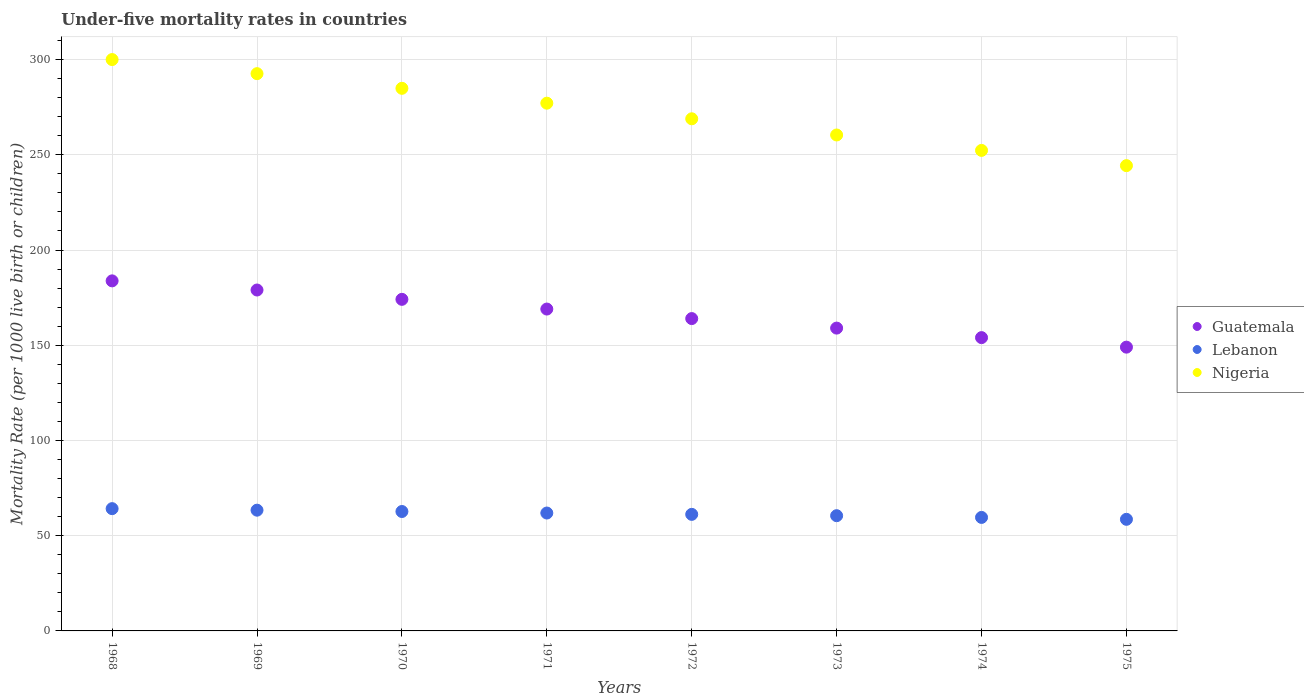How many different coloured dotlines are there?
Make the answer very short. 3. What is the under-five mortality rate in Nigeria in 1972?
Your answer should be compact. 268.9. Across all years, what is the maximum under-five mortality rate in Lebanon?
Give a very brief answer. 64.2. Across all years, what is the minimum under-five mortality rate in Nigeria?
Your answer should be very brief. 244.3. In which year was the under-five mortality rate in Nigeria maximum?
Your answer should be very brief. 1968. In which year was the under-five mortality rate in Nigeria minimum?
Your answer should be very brief. 1975. What is the total under-five mortality rate in Lebanon in the graph?
Offer a very short reply. 492.1. What is the difference between the under-five mortality rate in Nigeria in 1969 and the under-five mortality rate in Lebanon in 1968?
Provide a succinct answer. 228.4. What is the average under-five mortality rate in Lebanon per year?
Your answer should be very brief. 61.51. In the year 1970, what is the difference between the under-five mortality rate in Lebanon and under-five mortality rate in Guatemala?
Your response must be concise. -111.4. What is the ratio of the under-five mortality rate in Guatemala in 1969 to that in 1971?
Keep it short and to the point. 1.06. Is the under-five mortality rate in Guatemala in 1974 less than that in 1975?
Your answer should be compact. No. What is the difference between the highest and the second highest under-five mortality rate in Lebanon?
Provide a short and direct response. 0.8. What is the difference between the highest and the lowest under-five mortality rate in Nigeria?
Offer a terse response. 55.7. Is the sum of the under-five mortality rate in Guatemala in 1968 and 1973 greater than the maximum under-five mortality rate in Nigeria across all years?
Offer a very short reply. Yes. Does the under-five mortality rate in Nigeria monotonically increase over the years?
Provide a short and direct response. No. Is the under-five mortality rate in Guatemala strictly less than the under-five mortality rate in Lebanon over the years?
Make the answer very short. No. How many dotlines are there?
Keep it short and to the point. 3. Are the values on the major ticks of Y-axis written in scientific E-notation?
Offer a terse response. No. Does the graph contain any zero values?
Give a very brief answer. No. Does the graph contain grids?
Make the answer very short. Yes. How many legend labels are there?
Offer a very short reply. 3. How are the legend labels stacked?
Offer a terse response. Vertical. What is the title of the graph?
Provide a succinct answer. Under-five mortality rates in countries. What is the label or title of the Y-axis?
Make the answer very short. Mortality Rate (per 1000 live birth or children). What is the Mortality Rate (per 1000 live birth or children) of Guatemala in 1968?
Provide a short and direct response. 183.8. What is the Mortality Rate (per 1000 live birth or children) of Lebanon in 1968?
Ensure brevity in your answer.  64.2. What is the Mortality Rate (per 1000 live birth or children) of Nigeria in 1968?
Give a very brief answer. 300. What is the Mortality Rate (per 1000 live birth or children) of Guatemala in 1969?
Give a very brief answer. 179. What is the Mortality Rate (per 1000 live birth or children) of Lebanon in 1969?
Your response must be concise. 63.4. What is the Mortality Rate (per 1000 live birth or children) in Nigeria in 1969?
Make the answer very short. 292.6. What is the Mortality Rate (per 1000 live birth or children) in Guatemala in 1970?
Ensure brevity in your answer.  174.1. What is the Mortality Rate (per 1000 live birth or children) of Lebanon in 1970?
Provide a succinct answer. 62.7. What is the Mortality Rate (per 1000 live birth or children) of Nigeria in 1970?
Offer a very short reply. 284.9. What is the Mortality Rate (per 1000 live birth or children) of Guatemala in 1971?
Provide a succinct answer. 169. What is the Mortality Rate (per 1000 live birth or children) in Lebanon in 1971?
Ensure brevity in your answer.  61.9. What is the Mortality Rate (per 1000 live birth or children) of Nigeria in 1971?
Keep it short and to the point. 277.1. What is the Mortality Rate (per 1000 live birth or children) in Guatemala in 1972?
Provide a succinct answer. 164. What is the Mortality Rate (per 1000 live birth or children) in Lebanon in 1972?
Make the answer very short. 61.2. What is the Mortality Rate (per 1000 live birth or children) in Nigeria in 1972?
Your answer should be compact. 268.9. What is the Mortality Rate (per 1000 live birth or children) in Guatemala in 1973?
Your answer should be very brief. 159. What is the Mortality Rate (per 1000 live birth or children) of Lebanon in 1973?
Make the answer very short. 60.5. What is the Mortality Rate (per 1000 live birth or children) in Nigeria in 1973?
Offer a very short reply. 260.4. What is the Mortality Rate (per 1000 live birth or children) of Guatemala in 1974?
Offer a very short reply. 154. What is the Mortality Rate (per 1000 live birth or children) of Lebanon in 1974?
Ensure brevity in your answer.  59.6. What is the Mortality Rate (per 1000 live birth or children) of Nigeria in 1974?
Provide a succinct answer. 252.3. What is the Mortality Rate (per 1000 live birth or children) of Guatemala in 1975?
Make the answer very short. 149. What is the Mortality Rate (per 1000 live birth or children) of Lebanon in 1975?
Ensure brevity in your answer.  58.6. What is the Mortality Rate (per 1000 live birth or children) of Nigeria in 1975?
Give a very brief answer. 244.3. Across all years, what is the maximum Mortality Rate (per 1000 live birth or children) of Guatemala?
Offer a terse response. 183.8. Across all years, what is the maximum Mortality Rate (per 1000 live birth or children) of Lebanon?
Keep it short and to the point. 64.2. Across all years, what is the maximum Mortality Rate (per 1000 live birth or children) in Nigeria?
Give a very brief answer. 300. Across all years, what is the minimum Mortality Rate (per 1000 live birth or children) in Guatemala?
Offer a very short reply. 149. Across all years, what is the minimum Mortality Rate (per 1000 live birth or children) of Lebanon?
Make the answer very short. 58.6. Across all years, what is the minimum Mortality Rate (per 1000 live birth or children) of Nigeria?
Your response must be concise. 244.3. What is the total Mortality Rate (per 1000 live birth or children) of Guatemala in the graph?
Ensure brevity in your answer.  1331.9. What is the total Mortality Rate (per 1000 live birth or children) of Lebanon in the graph?
Your answer should be compact. 492.1. What is the total Mortality Rate (per 1000 live birth or children) of Nigeria in the graph?
Offer a terse response. 2180.5. What is the difference between the Mortality Rate (per 1000 live birth or children) of Lebanon in 1968 and that in 1969?
Ensure brevity in your answer.  0.8. What is the difference between the Mortality Rate (per 1000 live birth or children) of Lebanon in 1968 and that in 1970?
Your response must be concise. 1.5. What is the difference between the Mortality Rate (per 1000 live birth or children) of Nigeria in 1968 and that in 1971?
Ensure brevity in your answer.  22.9. What is the difference between the Mortality Rate (per 1000 live birth or children) of Guatemala in 1968 and that in 1972?
Ensure brevity in your answer.  19.8. What is the difference between the Mortality Rate (per 1000 live birth or children) of Lebanon in 1968 and that in 1972?
Offer a very short reply. 3. What is the difference between the Mortality Rate (per 1000 live birth or children) of Nigeria in 1968 and that in 1972?
Ensure brevity in your answer.  31.1. What is the difference between the Mortality Rate (per 1000 live birth or children) of Guatemala in 1968 and that in 1973?
Make the answer very short. 24.8. What is the difference between the Mortality Rate (per 1000 live birth or children) in Lebanon in 1968 and that in 1973?
Make the answer very short. 3.7. What is the difference between the Mortality Rate (per 1000 live birth or children) of Nigeria in 1968 and that in 1973?
Your answer should be compact. 39.6. What is the difference between the Mortality Rate (per 1000 live birth or children) in Guatemala in 1968 and that in 1974?
Keep it short and to the point. 29.8. What is the difference between the Mortality Rate (per 1000 live birth or children) in Lebanon in 1968 and that in 1974?
Ensure brevity in your answer.  4.6. What is the difference between the Mortality Rate (per 1000 live birth or children) in Nigeria in 1968 and that in 1974?
Your answer should be compact. 47.7. What is the difference between the Mortality Rate (per 1000 live birth or children) in Guatemala in 1968 and that in 1975?
Offer a very short reply. 34.8. What is the difference between the Mortality Rate (per 1000 live birth or children) of Lebanon in 1968 and that in 1975?
Provide a succinct answer. 5.6. What is the difference between the Mortality Rate (per 1000 live birth or children) in Nigeria in 1968 and that in 1975?
Provide a short and direct response. 55.7. What is the difference between the Mortality Rate (per 1000 live birth or children) in Guatemala in 1969 and that in 1971?
Make the answer very short. 10. What is the difference between the Mortality Rate (per 1000 live birth or children) in Lebanon in 1969 and that in 1971?
Offer a terse response. 1.5. What is the difference between the Mortality Rate (per 1000 live birth or children) in Nigeria in 1969 and that in 1972?
Your answer should be compact. 23.7. What is the difference between the Mortality Rate (per 1000 live birth or children) of Lebanon in 1969 and that in 1973?
Keep it short and to the point. 2.9. What is the difference between the Mortality Rate (per 1000 live birth or children) in Nigeria in 1969 and that in 1973?
Make the answer very short. 32.2. What is the difference between the Mortality Rate (per 1000 live birth or children) of Lebanon in 1969 and that in 1974?
Give a very brief answer. 3.8. What is the difference between the Mortality Rate (per 1000 live birth or children) of Nigeria in 1969 and that in 1974?
Your response must be concise. 40.3. What is the difference between the Mortality Rate (per 1000 live birth or children) in Lebanon in 1969 and that in 1975?
Offer a terse response. 4.8. What is the difference between the Mortality Rate (per 1000 live birth or children) of Nigeria in 1969 and that in 1975?
Your answer should be very brief. 48.3. What is the difference between the Mortality Rate (per 1000 live birth or children) in Lebanon in 1970 and that in 1971?
Your answer should be very brief. 0.8. What is the difference between the Mortality Rate (per 1000 live birth or children) of Lebanon in 1970 and that in 1972?
Keep it short and to the point. 1.5. What is the difference between the Mortality Rate (per 1000 live birth or children) in Nigeria in 1970 and that in 1972?
Offer a very short reply. 16. What is the difference between the Mortality Rate (per 1000 live birth or children) of Guatemala in 1970 and that in 1973?
Your answer should be very brief. 15.1. What is the difference between the Mortality Rate (per 1000 live birth or children) in Nigeria in 1970 and that in 1973?
Provide a succinct answer. 24.5. What is the difference between the Mortality Rate (per 1000 live birth or children) of Guatemala in 1970 and that in 1974?
Offer a very short reply. 20.1. What is the difference between the Mortality Rate (per 1000 live birth or children) in Lebanon in 1970 and that in 1974?
Offer a very short reply. 3.1. What is the difference between the Mortality Rate (per 1000 live birth or children) of Nigeria in 1970 and that in 1974?
Offer a very short reply. 32.6. What is the difference between the Mortality Rate (per 1000 live birth or children) of Guatemala in 1970 and that in 1975?
Your answer should be very brief. 25.1. What is the difference between the Mortality Rate (per 1000 live birth or children) in Nigeria in 1970 and that in 1975?
Provide a short and direct response. 40.6. What is the difference between the Mortality Rate (per 1000 live birth or children) of Guatemala in 1971 and that in 1972?
Your answer should be compact. 5. What is the difference between the Mortality Rate (per 1000 live birth or children) in Lebanon in 1971 and that in 1972?
Keep it short and to the point. 0.7. What is the difference between the Mortality Rate (per 1000 live birth or children) in Nigeria in 1971 and that in 1972?
Offer a very short reply. 8.2. What is the difference between the Mortality Rate (per 1000 live birth or children) in Lebanon in 1971 and that in 1973?
Ensure brevity in your answer.  1.4. What is the difference between the Mortality Rate (per 1000 live birth or children) of Guatemala in 1971 and that in 1974?
Keep it short and to the point. 15. What is the difference between the Mortality Rate (per 1000 live birth or children) of Lebanon in 1971 and that in 1974?
Offer a terse response. 2.3. What is the difference between the Mortality Rate (per 1000 live birth or children) of Nigeria in 1971 and that in 1974?
Offer a very short reply. 24.8. What is the difference between the Mortality Rate (per 1000 live birth or children) in Guatemala in 1971 and that in 1975?
Keep it short and to the point. 20. What is the difference between the Mortality Rate (per 1000 live birth or children) in Lebanon in 1971 and that in 1975?
Offer a terse response. 3.3. What is the difference between the Mortality Rate (per 1000 live birth or children) of Nigeria in 1971 and that in 1975?
Offer a very short reply. 32.8. What is the difference between the Mortality Rate (per 1000 live birth or children) of Lebanon in 1972 and that in 1973?
Offer a terse response. 0.7. What is the difference between the Mortality Rate (per 1000 live birth or children) of Lebanon in 1972 and that in 1974?
Provide a short and direct response. 1.6. What is the difference between the Mortality Rate (per 1000 live birth or children) in Nigeria in 1972 and that in 1974?
Ensure brevity in your answer.  16.6. What is the difference between the Mortality Rate (per 1000 live birth or children) in Lebanon in 1972 and that in 1975?
Your answer should be compact. 2.6. What is the difference between the Mortality Rate (per 1000 live birth or children) in Nigeria in 1972 and that in 1975?
Keep it short and to the point. 24.6. What is the difference between the Mortality Rate (per 1000 live birth or children) in Nigeria in 1973 and that in 1975?
Provide a succinct answer. 16.1. What is the difference between the Mortality Rate (per 1000 live birth or children) of Guatemala in 1974 and that in 1975?
Keep it short and to the point. 5. What is the difference between the Mortality Rate (per 1000 live birth or children) of Nigeria in 1974 and that in 1975?
Your answer should be compact. 8. What is the difference between the Mortality Rate (per 1000 live birth or children) in Guatemala in 1968 and the Mortality Rate (per 1000 live birth or children) in Lebanon in 1969?
Provide a short and direct response. 120.4. What is the difference between the Mortality Rate (per 1000 live birth or children) of Guatemala in 1968 and the Mortality Rate (per 1000 live birth or children) of Nigeria in 1969?
Ensure brevity in your answer.  -108.8. What is the difference between the Mortality Rate (per 1000 live birth or children) in Lebanon in 1968 and the Mortality Rate (per 1000 live birth or children) in Nigeria in 1969?
Provide a short and direct response. -228.4. What is the difference between the Mortality Rate (per 1000 live birth or children) of Guatemala in 1968 and the Mortality Rate (per 1000 live birth or children) of Lebanon in 1970?
Offer a terse response. 121.1. What is the difference between the Mortality Rate (per 1000 live birth or children) of Guatemala in 1968 and the Mortality Rate (per 1000 live birth or children) of Nigeria in 1970?
Provide a short and direct response. -101.1. What is the difference between the Mortality Rate (per 1000 live birth or children) of Lebanon in 1968 and the Mortality Rate (per 1000 live birth or children) of Nigeria in 1970?
Make the answer very short. -220.7. What is the difference between the Mortality Rate (per 1000 live birth or children) in Guatemala in 1968 and the Mortality Rate (per 1000 live birth or children) in Lebanon in 1971?
Offer a very short reply. 121.9. What is the difference between the Mortality Rate (per 1000 live birth or children) of Guatemala in 1968 and the Mortality Rate (per 1000 live birth or children) of Nigeria in 1971?
Provide a short and direct response. -93.3. What is the difference between the Mortality Rate (per 1000 live birth or children) of Lebanon in 1968 and the Mortality Rate (per 1000 live birth or children) of Nigeria in 1971?
Keep it short and to the point. -212.9. What is the difference between the Mortality Rate (per 1000 live birth or children) in Guatemala in 1968 and the Mortality Rate (per 1000 live birth or children) in Lebanon in 1972?
Keep it short and to the point. 122.6. What is the difference between the Mortality Rate (per 1000 live birth or children) in Guatemala in 1968 and the Mortality Rate (per 1000 live birth or children) in Nigeria in 1972?
Your answer should be compact. -85.1. What is the difference between the Mortality Rate (per 1000 live birth or children) in Lebanon in 1968 and the Mortality Rate (per 1000 live birth or children) in Nigeria in 1972?
Your answer should be very brief. -204.7. What is the difference between the Mortality Rate (per 1000 live birth or children) of Guatemala in 1968 and the Mortality Rate (per 1000 live birth or children) of Lebanon in 1973?
Your answer should be very brief. 123.3. What is the difference between the Mortality Rate (per 1000 live birth or children) in Guatemala in 1968 and the Mortality Rate (per 1000 live birth or children) in Nigeria in 1973?
Keep it short and to the point. -76.6. What is the difference between the Mortality Rate (per 1000 live birth or children) in Lebanon in 1968 and the Mortality Rate (per 1000 live birth or children) in Nigeria in 1973?
Offer a very short reply. -196.2. What is the difference between the Mortality Rate (per 1000 live birth or children) in Guatemala in 1968 and the Mortality Rate (per 1000 live birth or children) in Lebanon in 1974?
Keep it short and to the point. 124.2. What is the difference between the Mortality Rate (per 1000 live birth or children) of Guatemala in 1968 and the Mortality Rate (per 1000 live birth or children) of Nigeria in 1974?
Your answer should be compact. -68.5. What is the difference between the Mortality Rate (per 1000 live birth or children) of Lebanon in 1968 and the Mortality Rate (per 1000 live birth or children) of Nigeria in 1974?
Provide a short and direct response. -188.1. What is the difference between the Mortality Rate (per 1000 live birth or children) in Guatemala in 1968 and the Mortality Rate (per 1000 live birth or children) in Lebanon in 1975?
Your answer should be very brief. 125.2. What is the difference between the Mortality Rate (per 1000 live birth or children) of Guatemala in 1968 and the Mortality Rate (per 1000 live birth or children) of Nigeria in 1975?
Offer a very short reply. -60.5. What is the difference between the Mortality Rate (per 1000 live birth or children) of Lebanon in 1968 and the Mortality Rate (per 1000 live birth or children) of Nigeria in 1975?
Offer a terse response. -180.1. What is the difference between the Mortality Rate (per 1000 live birth or children) of Guatemala in 1969 and the Mortality Rate (per 1000 live birth or children) of Lebanon in 1970?
Your answer should be very brief. 116.3. What is the difference between the Mortality Rate (per 1000 live birth or children) in Guatemala in 1969 and the Mortality Rate (per 1000 live birth or children) in Nigeria in 1970?
Provide a short and direct response. -105.9. What is the difference between the Mortality Rate (per 1000 live birth or children) in Lebanon in 1969 and the Mortality Rate (per 1000 live birth or children) in Nigeria in 1970?
Offer a very short reply. -221.5. What is the difference between the Mortality Rate (per 1000 live birth or children) of Guatemala in 1969 and the Mortality Rate (per 1000 live birth or children) of Lebanon in 1971?
Your answer should be compact. 117.1. What is the difference between the Mortality Rate (per 1000 live birth or children) of Guatemala in 1969 and the Mortality Rate (per 1000 live birth or children) of Nigeria in 1971?
Make the answer very short. -98.1. What is the difference between the Mortality Rate (per 1000 live birth or children) in Lebanon in 1969 and the Mortality Rate (per 1000 live birth or children) in Nigeria in 1971?
Provide a succinct answer. -213.7. What is the difference between the Mortality Rate (per 1000 live birth or children) in Guatemala in 1969 and the Mortality Rate (per 1000 live birth or children) in Lebanon in 1972?
Provide a succinct answer. 117.8. What is the difference between the Mortality Rate (per 1000 live birth or children) of Guatemala in 1969 and the Mortality Rate (per 1000 live birth or children) of Nigeria in 1972?
Make the answer very short. -89.9. What is the difference between the Mortality Rate (per 1000 live birth or children) of Lebanon in 1969 and the Mortality Rate (per 1000 live birth or children) of Nigeria in 1972?
Keep it short and to the point. -205.5. What is the difference between the Mortality Rate (per 1000 live birth or children) in Guatemala in 1969 and the Mortality Rate (per 1000 live birth or children) in Lebanon in 1973?
Provide a short and direct response. 118.5. What is the difference between the Mortality Rate (per 1000 live birth or children) of Guatemala in 1969 and the Mortality Rate (per 1000 live birth or children) of Nigeria in 1973?
Offer a terse response. -81.4. What is the difference between the Mortality Rate (per 1000 live birth or children) in Lebanon in 1969 and the Mortality Rate (per 1000 live birth or children) in Nigeria in 1973?
Your answer should be very brief. -197. What is the difference between the Mortality Rate (per 1000 live birth or children) of Guatemala in 1969 and the Mortality Rate (per 1000 live birth or children) of Lebanon in 1974?
Give a very brief answer. 119.4. What is the difference between the Mortality Rate (per 1000 live birth or children) in Guatemala in 1969 and the Mortality Rate (per 1000 live birth or children) in Nigeria in 1974?
Your answer should be very brief. -73.3. What is the difference between the Mortality Rate (per 1000 live birth or children) of Lebanon in 1969 and the Mortality Rate (per 1000 live birth or children) of Nigeria in 1974?
Your answer should be compact. -188.9. What is the difference between the Mortality Rate (per 1000 live birth or children) in Guatemala in 1969 and the Mortality Rate (per 1000 live birth or children) in Lebanon in 1975?
Your answer should be compact. 120.4. What is the difference between the Mortality Rate (per 1000 live birth or children) in Guatemala in 1969 and the Mortality Rate (per 1000 live birth or children) in Nigeria in 1975?
Keep it short and to the point. -65.3. What is the difference between the Mortality Rate (per 1000 live birth or children) in Lebanon in 1969 and the Mortality Rate (per 1000 live birth or children) in Nigeria in 1975?
Your answer should be compact. -180.9. What is the difference between the Mortality Rate (per 1000 live birth or children) of Guatemala in 1970 and the Mortality Rate (per 1000 live birth or children) of Lebanon in 1971?
Offer a very short reply. 112.2. What is the difference between the Mortality Rate (per 1000 live birth or children) in Guatemala in 1970 and the Mortality Rate (per 1000 live birth or children) in Nigeria in 1971?
Give a very brief answer. -103. What is the difference between the Mortality Rate (per 1000 live birth or children) in Lebanon in 1970 and the Mortality Rate (per 1000 live birth or children) in Nigeria in 1971?
Your answer should be compact. -214.4. What is the difference between the Mortality Rate (per 1000 live birth or children) of Guatemala in 1970 and the Mortality Rate (per 1000 live birth or children) of Lebanon in 1972?
Provide a short and direct response. 112.9. What is the difference between the Mortality Rate (per 1000 live birth or children) in Guatemala in 1970 and the Mortality Rate (per 1000 live birth or children) in Nigeria in 1972?
Keep it short and to the point. -94.8. What is the difference between the Mortality Rate (per 1000 live birth or children) in Lebanon in 1970 and the Mortality Rate (per 1000 live birth or children) in Nigeria in 1972?
Offer a terse response. -206.2. What is the difference between the Mortality Rate (per 1000 live birth or children) of Guatemala in 1970 and the Mortality Rate (per 1000 live birth or children) of Lebanon in 1973?
Ensure brevity in your answer.  113.6. What is the difference between the Mortality Rate (per 1000 live birth or children) in Guatemala in 1970 and the Mortality Rate (per 1000 live birth or children) in Nigeria in 1973?
Give a very brief answer. -86.3. What is the difference between the Mortality Rate (per 1000 live birth or children) in Lebanon in 1970 and the Mortality Rate (per 1000 live birth or children) in Nigeria in 1973?
Offer a very short reply. -197.7. What is the difference between the Mortality Rate (per 1000 live birth or children) in Guatemala in 1970 and the Mortality Rate (per 1000 live birth or children) in Lebanon in 1974?
Make the answer very short. 114.5. What is the difference between the Mortality Rate (per 1000 live birth or children) of Guatemala in 1970 and the Mortality Rate (per 1000 live birth or children) of Nigeria in 1974?
Keep it short and to the point. -78.2. What is the difference between the Mortality Rate (per 1000 live birth or children) in Lebanon in 1970 and the Mortality Rate (per 1000 live birth or children) in Nigeria in 1974?
Provide a short and direct response. -189.6. What is the difference between the Mortality Rate (per 1000 live birth or children) in Guatemala in 1970 and the Mortality Rate (per 1000 live birth or children) in Lebanon in 1975?
Keep it short and to the point. 115.5. What is the difference between the Mortality Rate (per 1000 live birth or children) in Guatemala in 1970 and the Mortality Rate (per 1000 live birth or children) in Nigeria in 1975?
Give a very brief answer. -70.2. What is the difference between the Mortality Rate (per 1000 live birth or children) in Lebanon in 1970 and the Mortality Rate (per 1000 live birth or children) in Nigeria in 1975?
Offer a very short reply. -181.6. What is the difference between the Mortality Rate (per 1000 live birth or children) in Guatemala in 1971 and the Mortality Rate (per 1000 live birth or children) in Lebanon in 1972?
Ensure brevity in your answer.  107.8. What is the difference between the Mortality Rate (per 1000 live birth or children) in Guatemala in 1971 and the Mortality Rate (per 1000 live birth or children) in Nigeria in 1972?
Provide a succinct answer. -99.9. What is the difference between the Mortality Rate (per 1000 live birth or children) in Lebanon in 1971 and the Mortality Rate (per 1000 live birth or children) in Nigeria in 1972?
Provide a succinct answer. -207. What is the difference between the Mortality Rate (per 1000 live birth or children) in Guatemala in 1971 and the Mortality Rate (per 1000 live birth or children) in Lebanon in 1973?
Provide a succinct answer. 108.5. What is the difference between the Mortality Rate (per 1000 live birth or children) in Guatemala in 1971 and the Mortality Rate (per 1000 live birth or children) in Nigeria in 1973?
Offer a very short reply. -91.4. What is the difference between the Mortality Rate (per 1000 live birth or children) in Lebanon in 1971 and the Mortality Rate (per 1000 live birth or children) in Nigeria in 1973?
Ensure brevity in your answer.  -198.5. What is the difference between the Mortality Rate (per 1000 live birth or children) in Guatemala in 1971 and the Mortality Rate (per 1000 live birth or children) in Lebanon in 1974?
Ensure brevity in your answer.  109.4. What is the difference between the Mortality Rate (per 1000 live birth or children) of Guatemala in 1971 and the Mortality Rate (per 1000 live birth or children) of Nigeria in 1974?
Provide a short and direct response. -83.3. What is the difference between the Mortality Rate (per 1000 live birth or children) in Lebanon in 1971 and the Mortality Rate (per 1000 live birth or children) in Nigeria in 1974?
Ensure brevity in your answer.  -190.4. What is the difference between the Mortality Rate (per 1000 live birth or children) of Guatemala in 1971 and the Mortality Rate (per 1000 live birth or children) of Lebanon in 1975?
Keep it short and to the point. 110.4. What is the difference between the Mortality Rate (per 1000 live birth or children) in Guatemala in 1971 and the Mortality Rate (per 1000 live birth or children) in Nigeria in 1975?
Offer a terse response. -75.3. What is the difference between the Mortality Rate (per 1000 live birth or children) in Lebanon in 1971 and the Mortality Rate (per 1000 live birth or children) in Nigeria in 1975?
Keep it short and to the point. -182.4. What is the difference between the Mortality Rate (per 1000 live birth or children) of Guatemala in 1972 and the Mortality Rate (per 1000 live birth or children) of Lebanon in 1973?
Offer a terse response. 103.5. What is the difference between the Mortality Rate (per 1000 live birth or children) in Guatemala in 1972 and the Mortality Rate (per 1000 live birth or children) in Nigeria in 1973?
Provide a short and direct response. -96.4. What is the difference between the Mortality Rate (per 1000 live birth or children) of Lebanon in 1972 and the Mortality Rate (per 1000 live birth or children) of Nigeria in 1973?
Offer a very short reply. -199.2. What is the difference between the Mortality Rate (per 1000 live birth or children) in Guatemala in 1972 and the Mortality Rate (per 1000 live birth or children) in Lebanon in 1974?
Ensure brevity in your answer.  104.4. What is the difference between the Mortality Rate (per 1000 live birth or children) of Guatemala in 1972 and the Mortality Rate (per 1000 live birth or children) of Nigeria in 1974?
Provide a succinct answer. -88.3. What is the difference between the Mortality Rate (per 1000 live birth or children) in Lebanon in 1972 and the Mortality Rate (per 1000 live birth or children) in Nigeria in 1974?
Provide a short and direct response. -191.1. What is the difference between the Mortality Rate (per 1000 live birth or children) in Guatemala in 1972 and the Mortality Rate (per 1000 live birth or children) in Lebanon in 1975?
Offer a terse response. 105.4. What is the difference between the Mortality Rate (per 1000 live birth or children) in Guatemala in 1972 and the Mortality Rate (per 1000 live birth or children) in Nigeria in 1975?
Provide a short and direct response. -80.3. What is the difference between the Mortality Rate (per 1000 live birth or children) of Lebanon in 1972 and the Mortality Rate (per 1000 live birth or children) of Nigeria in 1975?
Offer a very short reply. -183.1. What is the difference between the Mortality Rate (per 1000 live birth or children) in Guatemala in 1973 and the Mortality Rate (per 1000 live birth or children) in Lebanon in 1974?
Provide a succinct answer. 99.4. What is the difference between the Mortality Rate (per 1000 live birth or children) in Guatemala in 1973 and the Mortality Rate (per 1000 live birth or children) in Nigeria in 1974?
Ensure brevity in your answer.  -93.3. What is the difference between the Mortality Rate (per 1000 live birth or children) of Lebanon in 1973 and the Mortality Rate (per 1000 live birth or children) of Nigeria in 1974?
Your response must be concise. -191.8. What is the difference between the Mortality Rate (per 1000 live birth or children) in Guatemala in 1973 and the Mortality Rate (per 1000 live birth or children) in Lebanon in 1975?
Offer a terse response. 100.4. What is the difference between the Mortality Rate (per 1000 live birth or children) in Guatemala in 1973 and the Mortality Rate (per 1000 live birth or children) in Nigeria in 1975?
Provide a succinct answer. -85.3. What is the difference between the Mortality Rate (per 1000 live birth or children) in Lebanon in 1973 and the Mortality Rate (per 1000 live birth or children) in Nigeria in 1975?
Provide a short and direct response. -183.8. What is the difference between the Mortality Rate (per 1000 live birth or children) of Guatemala in 1974 and the Mortality Rate (per 1000 live birth or children) of Lebanon in 1975?
Keep it short and to the point. 95.4. What is the difference between the Mortality Rate (per 1000 live birth or children) of Guatemala in 1974 and the Mortality Rate (per 1000 live birth or children) of Nigeria in 1975?
Give a very brief answer. -90.3. What is the difference between the Mortality Rate (per 1000 live birth or children) in Lebanon in 1974 and the Mortality Rate (per 1000 live birth or children) in Nigeria in 1975?
Your answer should be very brief. -184.7. What is the average Mortality Rate (per 1000 live birth or children) in Guatemala per year?
Your answer should be very brief. 166.49. What is the average Mortality Rate (per 1000 live birth or children) in Lebanon per year?
Keep it short and to the point. 61.51. What is the average Mortality Rate (per 1000 live birth or children) of Nigeria per year?
Your answer should be compact. 272.56. In the year 1968, what is the difference between the Mortality Rate (per 1000 live birth or children) of Guatemala and Mortality Rate (per 1000 live birth or children) of Lebanon?
Make the answer very short. 119.6. In the year 1968, what is the difference between the Mortality Rate (per 1000 live birth or children) in Guatemala and Mortality Rate (per 1000 live birth or children) in Nigeria?
Offer a terse response. -116.2. In the year 1968, what is the difference between the Mortality Rate (per 1000 live birth or children) in Lebanon and Mortality Rate (per 1000 live birth or children) in Nigeria?
Your answer should be very brief. -235.8. In the year 1969, what is the difference between the Mortality Rate (per 1000 live birth or children) in Guatemala and Mortality Rate (per 1000 live birth or children) in Lebanon?
Ensure brevity in your answer.  115.6. In the year 1969, what is the difference between the Mortality Rate (per 1000 live birth or children) of Guatemala and Mortality Rate (per 1000 live birth or children) of Nigeria?
Your answer should be very brief. -113.6. In the year 1969, what is the difference between the Mortality Rate (per 1000 live birth or children) in Lebanon and Mortality Rate (per 1000 live birth or children) in Nigeria?
Offer a terse response. -229.2. In the year 1970, what is the difference between the Mortality Rate (per 1000 live birth or children) of Guatemala and Mortality Rate (per 1000 live birth or children) of Lebanon?
Offer a very short reply. 111.4. In the year 1970, what is the difference between the Mortality Rate (per 1000 live birth or children) in Guatemala and Mortality Rate (per 1000 live birth or children) in Nigeria?
Ensure brevity in your answer.  -110.8. In the year 1970, what is the difference between the Mortality Rate (per 1000 live birth or children) of Lebanon and Mortality Rate (per 1000 live birth or children) of Nigeria?
Provide a short and direct response. -222.2. In the year 1971, what is the difference between the Mortality Rate (per 1000 live birth or children) in Guatemala and Mortality Rate (per 1000 live birth or children) in Lebanon?
Your answer should be very brief. 107.1. In the year 1971, what is the difference between the Mortality Rate (per 1000 live birth or children) of Guatemala and Mortality Rate (per 1000 live birth or children) of Nigeria?
Give a very brief answer. -108.1. In the year 1971, what is the difference between the Mortality Rate (per 1000 live birth or children) of Lebanon and Mortality Rate (per 1000 live birth or children) of Nigeria?
Offer a very short reply. -215.2. In the year 1972, what is the difference between the Mortality Rate (per 1000 live birth or children) of Guatemala and Mortality Rate (per 1000 live birth or children) of Lebanon?
Your response must be concise. 102.8. In the year 1972, what is the difference between the Mortality Rate (per 1000 live birth or children) of Guatemala and Mortality Rate (per 1000 live birth or children) of Nigeria?
Keep it short and to the point. -104.9. In the year 1972, what is the difference between the Mortality Rate (per 1000 live birth or children) in Lebanon and Mortality Rate (per 1000 live birth or children) in Nigeria?
Ensure brevity in your answer.  -207.7. In the year 1973, what is the difference between the Mortality Rate (per 1000 live birth or children) of Guatemala and Mortality Rate (per 1000 live birth or children) of Lebanon?
Offer a terse response. 98.5. In the year 1973, what is the difference between the Mortality Rate (per 1000 live birth or children) of Guatemala and Mortality Rate (per 1000 live birth or children) of Nigeria?
Give a very brief answer. -101.4. In the year 1973, what is the difference between the Mortality Rate (per 1000 live birth or children) of Lebanon and Mortality Rate (per 1000 live birth or children) of Nigeria?
Provide a succinct answer. -199.9. In the year 1974, what is the difference between the Mortality Rate (per 1000 live birth or children) of Guatemala and Mortality Rate (per 1000 live birth or children) of Lebanon?
Offer a very short reply. 94.4. In the year 1974, what is the difference between the Mortality Rate (per 1000 live birth or children) in Guatemala and Mortality Rate (per 1000 live birth or children) in Nigeria?
Your response must be concise. -98.3. In the year 1974, what is the difference between the Mortality Rate (per 1000 live birth or children) of Lebanon and Mortality Rate (per 1000 live birth or children) of Nigeria?
Your answer should be very brief. -192.7. In the year 1975, what is the difference between the Mortality Rate (per 1000 live birth or children) of Guatemala and Mortality Rate (per 1000 live birth or children) of Lebanon?
Offer a very short reply. 90.4. In the year 1975, what is the difference between the Mortality Rate (per 1000 live birth or children) of Guatemala and Mortality Rate (per 1000 live birth or children) of Nigeria?
Your response must be concise. -95.3. In the year 1975, what is the difference between the Mortality Rate (per 1000 live birth or children) in Lebanon and Mortality Rate (per 1000 live birth or children) in Nigeria?
Your answer should be compact. -185.7. What is the ratio of the Mortality Rate (per 1000 live birth or children) in Guatemala in 1968 to that in 1969?
Give a very brief answer. 1.03. What is the ratio of the Mortality Rate (per 1000 live birth or children) of Lebanon in 1968 to that in 1969?
Your answer should be very brief. 1.01. What is the ratio of the Mortality Rate (per 1000 live birth or children) in Nigeria in 1968 to that in 1969?
Provide a succinct answer. 1.03. What is the ratio of the Mortality Rate (per 1000 live birth or children) in Guatemala in 1968 to that in 1970?
Your response must be concise. 1.06. What is the ratio of the Mortality Rate (per 1000 live birth or children) of Lebanon in 1968 to that in 1970?
Provide a short and direct response. 1.02. What is the ratio of the Mortality Rate (per 1000 live birth or children) of Nigeria in 1968 to that in 1970?
Your answer should be compact. 1.05. What is the ratio of the Mortality Rate (per 1000 live birth or children) in Guatemala in 1968 to that in 1971?
Provide a succinct answer. 1.09. What is the ratio of the Mortality Rate (per 1000 live birth or children) of Lebanon in 1968 to that in 1971?
Make the answer very short. 1.04. What is the ratio of the Mortality Rate (per 1000 live birth or children) in Nigeria in 1968 to that in 1971?
Offer a very short reply. 1.08. What is the ratio of the Mortality Rate (per 1000 live birth or children) of Guatemala in 1968 to that in 1972?
Ensure brevity in your answer.  1.12. What is the ratio of the Mortality Rate (per 1000 live birth or children) of Lebanon in 1968 to that in 1972?
Make the answer very short. 1.05. What is the ratio of the Mortality Rate (per 1000 live birth or children) of Nigeria in 1968 to that in 1972?
Give a very brief answer. 1.12. What is the ratio of the Mortality Rate (per 1000 live birth or children) of Guatemala in 1968 to that in 1973?
Make the answer very short. 1.16. What is the ratio of the Mortality Rate (per 1000 live birth or children) of Lebanon in 1968 to that in 1973?
Keep it short and to the point. 1.06. What is the ratio of the Mortality Rate (per 1000 live birth or children) of Nigeria in 1968 to that in 1973?
Give a very brief answer. 1.15. What is the ratio of the Mortality Rate (per 1000 live birth or children) in Guatemala in 1968 to that in 1974?
Ensure brevity in your answer.  1.19. What is the ratio of the Mortality Rate (per 1000 live birth or children) of Lebanon in 1968 to that in 1974?
Your answer should be compact. 1.08. What is the ratio of the Mortality Rate (per 1000 live birth or children) of Nigeria in 1968 to that in 1974?
Offer a very short reply. 1.19. What is the ratio of the Mortality Rate (per 1000 live birth or children) in Guatemala in 1968 to that in 1975?
Make the answer very short. 1.23. What is the ratio of the Mortality Rate (per 1000 live birth or children) of Lebanon in 1968 to that in 1975?
Your answer should be compact. 1.1. What is the ratio of the Mortality Rate (per 1000 live birth or children) in Nigeria in 1968 to that in 1975?
Make the answer very short. 1.23. What is the ratio of the Mortality Rate (per 1000 live birth or children) of Guatemala in 1969 to that in 1970?
Offer a very short reply. 1.03. What is the ratio of the Mortality Rate (per 1000 live birth or children) in Lebanon in 1969 to that in 1970?
Offer a very short reply. 1.01. What is the ratio of the Mortality Rate (per 1000 live birth or children) of Guatemala in 1969 to that in 1971?
Your response must be concise. 1.06. What is the ratio of the Mortality Rate (per 1000 live birth or children) of Lebanon in 1969 to that in 1971?
Offer a very short reply. 1.02. What is the ratio of the Mortality Rate (per 1000 live birth or children) of Nigeria in 1969 to that in 1971?
Provide a short and direct response. 1.06. What is the ratio of the Mortality Rate (per 1000 live birth or children) in Guatemala in 1969 to that in 1972?
Provide a short and direct response. 1.09. What is the ratio of the Mortality Rate (per 1000 live birth or children) of Lebanon in 1969 to that in 1972?
Your response must be concise. 1.04. What is the ratio of the Mortality Rate (per 1000 live birth or children) of Nigeria in 1969 to that in 1972?
Keep it short and to the point. 1.09. What is the ratio of the Mortality Rate (per 1000 live birth or children) in Guatemala in 1969 to that in 1973?
Your answer should be very brief. 1.13. What is the ratio of the Mortality Rate (per 1000 live birth or children) in Lebanon in 1969 to that in 1973?
Offer a very short reply. 1.05. What is the ratio of the Mortality Rate (per 1000 live birth or children) in Nigeria in 1969 to that in 1973?
Offer a terse response. 1.12. What is the ratio of the Mortality Rate (per 1000 live birth or children) of Guatemala in 1969 to that in 1974?
Provide a succinct answer. 1.16. What is the ratio of the Mortality Rate (per 1000 live birth or children) in Lebanon in 1969 to that in 1974?
Make the answer very short. 1.06. What is the ratio of the Mortality Rate (per 1000 live birth or children) in Nigeria in 1969 to that in 1974?
Provide a succinct answer. 1.16. What is the ratio of the Mortality Rate (per 1000 live birth or children) in Guatemala in 1969 to that in 1975?
Offer a terse response. 1.2. What is the ratio of the Mortality Rate (per 1000 live birth or children) in Lebanon in 1969 to that in 1975?
Give a very brief answer. 1.08. What is the ratio of the Mortality Rate (per 1000 live birth or children) of Nigeria in 1969 to that in 1975?
Your answer should be very brief. 1.2. What is the ratio of the Mortality Rate (per 1000 live birth or children) of Guatemala in 1970 to that in 1971?
Provide a short and direct response. 1.03. What is the ratio of the Mortality Rate (per 1000 live birth or children) of Lebanon in 1970 to that in 1971?
Make the answer very short. 1.01. What is the ratio of the Mortality Rate (per 1000 live birth or children) of Nigeria in 1970 to that in 1971?
Your answer should be very brief. 1.03. What is the ratio of the Mortality Rate (per 1000 live birth or children) of Guatemala in 1970 to that in 1972?
Offer a very short reply. 1.06. What is the ratio of the Mortality Rate (per 1000 live birth or children) in Lebanon in 1970 to that in 1972?
Make the answer very short. 1.02. What is the ratio of the Mortality Rate (per 1000 live birth or children) of Nigeria in 1970 to that in 1972?
Offer a terse response. 1.06. What is the ratio of the Mortality Rate (per 1000 live birth or children) of Guatemala in 1970 to that in 1973?
Your answer should be compact. 1.09. What is the ratio of the Mortality Rate (per 1000 live birth or children) of Lebanon in 1970 to that in 1973?
Give a very brief answer. 1.04. What is the ratio of the Mortality Rate (per 1000 live birth or children) of Nigeria in 1970 to that in 1973?
Offer a very short reply. 1.09. What is the ratio of the Mortality Rate (per 1000 live birth or children) of Guatemala in 1970 to that in 1974?
Offer a terse response. 1.13. What is the ratio of the Mortality Rate (per 1000 live birth or children) of Lebanon in 1970 to that in 1974?
Give a very brief answer. 1.05. What is the ratio of the Mortality Rate (per 1000 live birth or children) in Nigeria in 1970 to that in 1974?
Offer a very short reply. 1.13. What is the ratio of the Mortality Rate (per 1000 live birth or children) in Guatemala in 1970 to that in 1975?
Provide a succinct answer. 1.17. What is the ratio of the Mortality Rate (per 1000 live birth or children) in Lebanon in 1970 to that in 1975?
Make the answer very short. 1.07. What is the ratio of the Mortality Rate (per 1000 live birth or children) in Nigeria in 1970 to that in 1975?
Ensure brevity in your answer.  1.17. What is the ratio of the Mortality Rate (per 1000 live birth or children) in Guatemala in 1971 to that in 1972?
Provide a succinct answer. 1.03. What is the ratio of the Mortality Rate (per 1000 live birth or children) of Lebanon in 1971 to that in 1972?
Your answer should be compact. 1.01. What is the ratio of the Mortality Rate (per 1000 live birth or children) of Nigeria in 1971 to that in 1972?
Your answer should be compact. 1.03. What is the ratio of the Mortality Rate (per 1000 live birth or children) of Guatemala in 1971 to that in 1973?
Keep it short and to the point. 1.06. What is the ratio of the Mortality Rate (per 1000 live birth or children) of Lebanon in 1971 to that in 1973?
Your response must be concise. 1.02. What is the ratio of the Mortality Rate (per 1000 live birth or children) in Nigeria in 1971 to that in 1973?
Provide a short and direct response. 1.06. What is the ratio of the Mortality Rate (per 1000 live birth or children) in Guatemala in 1971 to that in 1974?
Offer a very short reply. 1.1. What is the ratio of the Mortality Rate (per 1000 live birth or children) of Lebanon in 1971 to that in 1974?
Offer a terse response. 1.04. What is the ratio of the Mortality Rate (per 1000 live birth or children) of Nigeria in 1971 to that in 1974?
Your answer should be very brief. 1.1. What is the ratio of the Mortality Rate (per 1000 live birth or children) in Guatemala in 1971 to that in 1975?
Keep it short and to the point. 1.13. What is the ratio of the Mortality Rate (per 1000 live birth or children) in Lebanon in 1971 to that in 1975?
Provide a short and direct response. 1.06. What is the ratio of the Mortality Rate (per 1000 live birth or children) of Nigeria in 1971 to that in 1975?
Provide a succinct answer. 1.13. What is the ratio of the Mortality Rate (per 1000 live birth or children) in Guatemala in 1972 to that in 1973?
Your answer should be very brief. 1.03. What is the ratio of the Mortality Rate (per 1000 live birth or children) of Lebanon in 1972 to that in 1973?
Keep it short and to the point. 1.01. What is the ratio of the Mortality Rate (per 1000 live birth or children) of Nigeria in 1972 to that in 1973?
Offer a terse response. 1.03. What is the ratio of the Mortality Rate (per 1000 live birth or children) in Guatemala in 1972 to that in 1974?
Make the answer very short. 1.06. What is the ratio of the Mortality Rate (per 1000 live birth or children) in Lebanon in 1972 to that in 1974?
Keep it short and to the point. 1.03. What is the ratio of the Mortality Rate (per 1000 live birth or children) of Nigeria in 1972 to that in 1974?
Your response must be concise. 1.07. What is the ratio of the Mortality Rate (per 1000 live birth or children) in Guatemala in 1972 to that in 1975?
Keep it short and to the point. 1.1. What is the ratio of the Mortality Rate (per 1000 live birth or children) in Lebanon in 1972 to that in 1975?
Your answer should be compact. 1.04. What is the ratio of the Mortality Rate (per 1000 live birth or children) in Nigeria in 1972 to that in 1975?
Your answer should be compact. 1.1. What is the ratio of the Mortality Rate (per 1000 live birth or children) of Guatemala in 1973 to that in 1974?
Offer a very short reply. 1.03. What is the ratio of the Mortality Rate (per 1000 live birth or children) of Lebanon in 1973 to that in 1974?
Your answer should be compact. 1.02. What is the ratio of the Mortality Rate (per 1000 live birth or children) of Nigeria in 1973 to that in 1974?
Your answer should be compact. 1.03. What is the ratio of the Mortality Rate (per 1000 live birth or children) in Guatemala in 1973 to that in 1975?
Ensure brevity in your answer.  1.07. What is the ratio of the Mortality Rate (per 1000 live birth or children) of Lebanon in 1973 to that in 1975?
Offer a terse response. 1.03. What is the ratio of the Mortality Rate (per 1000 live birth or children) of Nigeria in 1973 to that in 1975?
Keep it short and to the point. 1.07. What is the ratio of the Mortality Rate (per 1000 live birth or children) in Guatemala in 1974 to that in 1975?
Provide a short and direct response. 1.03. What is the ratio of the Mortality Rate (per 1000 live birth or children) of Lebanon in 1974 to that in 1975?
Provide a short and direct response. 1.02. What is the ratio of the Mortality Rate (per 1000 live birth or children) in Nigeria in 1974 to that in 1975?
Your answer should be compact. 1.03. What is the difference between the highest and the second highest Mortality Rate (per 1000 live birth or children) in Nigeria?
Your answer should be very brief. 7.4. What is the difference between the highest and the lowest Mortality Rate (per 1000 live birth or children) of Guatemala?
Provide a succinct answer. 34.8. What is the difference between the highest and the lowest Mortality Rate (per 1000 live birth or children) in Nigeria?
Offer a very short reply. 55.7. 